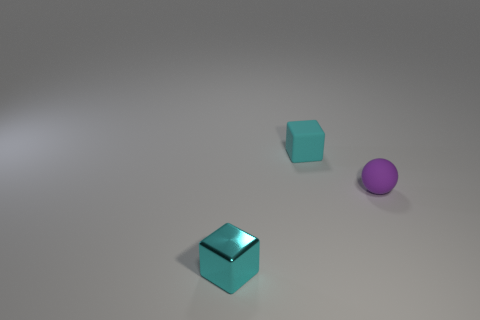What size is the other block that is the same color as the shiny block?
Make the answer very short. Small. There is a tiny matte object that is the same color as the metal object; what shape is it?
Offer a very short reply. Cube. There is a tiny rubber thing that is the same shape as the shiny thing; what color is it?
Offer a very short reply. Cyan. Are there any other things that have the same color as the matte ball?
Make the answer very short. No. What number of other things are the same material as the purple ball?
Offer a terse response. 1. What is the size of the cyan metallic thing?
Your response must be concise. Small. Are there any other purple objects of the same shape as the purple thing?
Ensure brevity in your answer.  No. How many objects are either metal cubes or tiny cyan cubes that are on the left side of the cyan rubber thing?
Offer a terse response. 1. What color is the cube that is behind the cyan shiny cube?
Give a very brief answer. Cyan. There is a cyan object that is behind the sphere; does it have the same size as the rubber object that is to the right of the small matte block?
Give a very brief answer. Yes. 